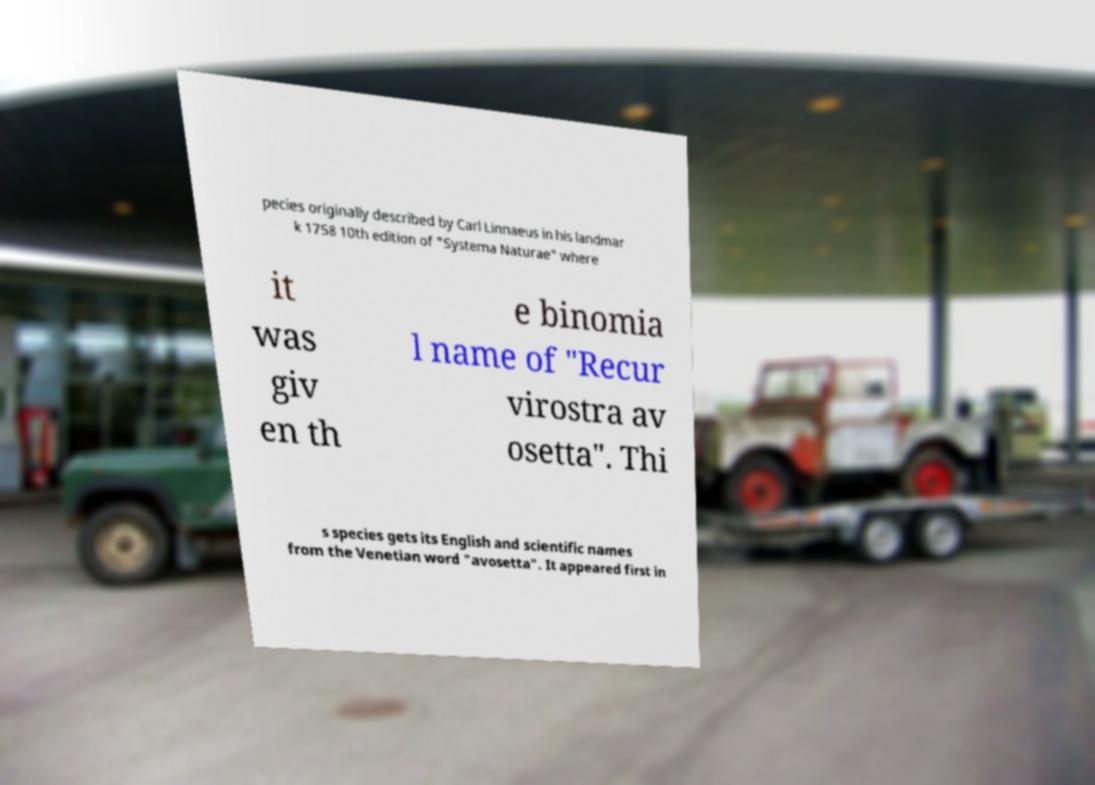Can you read and provide the text displayed in the image?This photo seems to have some interesting text. Can you extract and type it out for me? pecies originally described by Carl Linnaeus in his landmar k 1758 10th edition of "Systema Naturae" where it was giv en th e binomia l name of "Recur virostra av osetta". Thi s species gets its English and scientific names from the Venetian word "avosetta". It appeared first in 